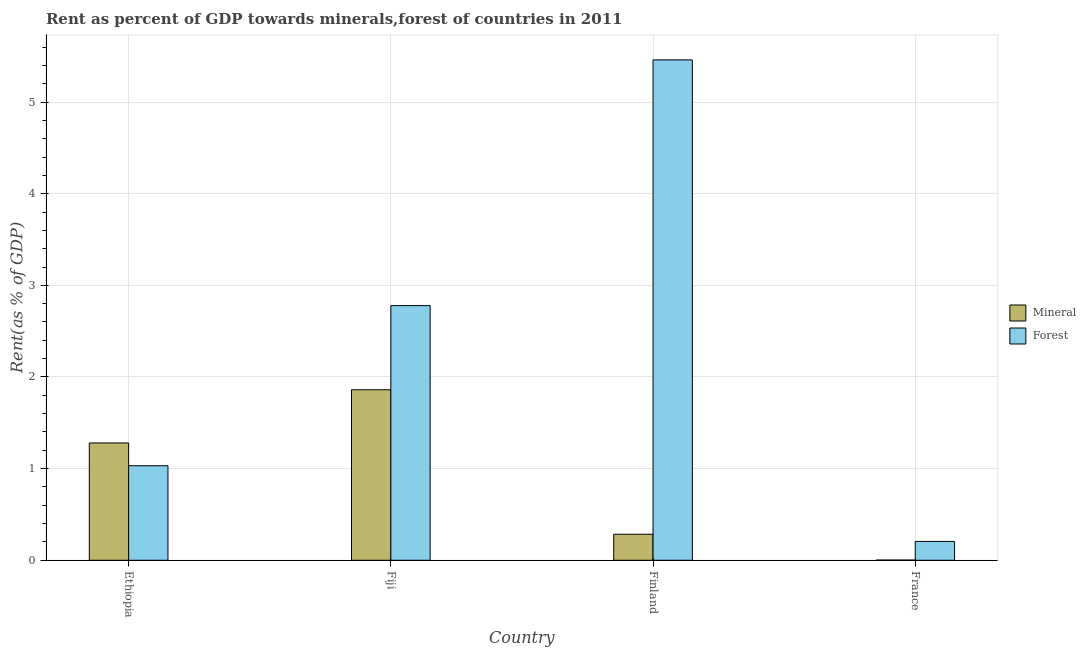How many groups of bars are there?
Offer a terse response. 4. How many bars are there on the 1st tick from the right?
Offer a terse response. 2. What is the label of the 1st group of bars from the left?
Give a very brief answer. Ethiopia. What is the mineral rent in Ethiopia?
Provide a short and direct response. 1.28. Across all countries, what is the maximum mineral rent?
Your answer should be very brief. 1.86. Across all countries, what is the minimum forest rent?
Provide a succinct answer. 0.21. What is the total mineral rent in the graph?
Offer a terse response. 3.43. What is the difference between the mineral rent in Ethiopia and that in Fiji?
Your answer should be compact. -0.58. What is the difference between the mineral rent in Fiji and the forest rent in Ethiopia?
Make the answer very short. 0.83. What is the average forest rent per country?
Offer a terse response. 2.37. What is the difference between the forest rent and mineral rent in Ethiopia?
Provide a succinct answer. -0.25. In how many countries, is the mineral rent greater than 5.2 %?
Offer a terse response. 0. What is the ratio of the mineral rent in Finland to that in France?
Provide a succinct answer. 131.69. What is the difference between the highest and the second highest forest rent?
Your answer should be very brief. 2.68. What is the difference between the highest and the lowest mineral rent?
Your answer should be very brief. 1.86. What does the 2nd bar from the left in Ethiopia represents?
Provide a short and direct response. Forest. What does the 1st bar from the right in France represents?
Ensure brevity in your answer.  Forest. Are all the bars in the graph horizontal?
Give a very brief answer. No. What is the difference between two consecutive major ticks on the Y-axis?
Provide a succinct answer. 1. Where does the legend appear in the graph?
Your answer should be compact. Center right. How many legend labels are there?
Your answer should be very brief. 2. How are the legend labels stacked?
Provide a short and direct response. Vertical. What is the title of the graph?
Give a very brief answer. Rent as percent of GDP towards minerals,forest of countries in 2011. Does "Services" appear as one of the legend labels in the graph?
Your answer should be compact. No. What is the label or title of the Y-axis?
Give a very brief answer. Rent(as % of GDP). What is the Rent(as % of GDP) in Mineral in Ethiopia?
Offer a terse response. 1.28. What is the Rent(as % of GDP) of Forest in Ethiopia?
Your response must be concise. 1.03. What is the Rent(as % of GDP) in Mineral in Fiji?
Offer a very short reply. 1.86. What is the Rent(as % of GDP) of Forest in Fiji?
Offer a very short reply. 2.78. What is the Rent(as % of GDP) of Mineral in Finland?
Provide a succinct answer. 0.28. What is the Rent(as % of GDP) in Forest in Finland?
Your response must be concise. 5.46. What is the Rent(as % of GDP) in Mineral in France?
Offer a very short reply. 0. What is the Rent(as % of GDP) of Forest in France?
Ensure brevity in your answer.  0.21. Across all countries, what is the maximum Rent(as % of GDP) of Mineral?
Give a very brief answer. 1.86. Across all countries, what is the maximum Rent(as % of GDP) of Forest?
Your response must be concise. 5.46. Across all countries, what is the minimum Rent(as % of GDP) of Mineral?
Your answer should be compact. 0. Across all countries, what is the minimum Rent(as % of GDP) in Forest?
Give a very brief answer. 0.21. What is the total Rent(as % of GDP) in Mineral in the graph?
Your answer should be very brief. 3.43. What is the total Rent(as % of GDP) in Forest in the graph?
Ensure brevity in your answer.  9.48. What is the difference between the Rent(as % of GDP) of Mineral in Ethiopia and that in Fiji?
Offer a terse response. -0.58. What is the difference between the Rent(as % of GDP) of Forest in Ethiopia and that in Fiji?
Offer a very short reply. -1.75. What is the difference between the Rent(as % of GDP) of Forest in Ethiopia and that in Finland?
Your answer should be very brief. -4.43. What is the difference between the Rent(as % of GDP) in Mineral in Ethiopia and that in France?
Ensure brevity in your answer.  1.28. What is the difference between the Rent(as % of GDP) in Forest in Ethiopia and that in France?
Offer a terse response. 0.83. What is the difference between the Rent(as % of GDP) of Mineral in Fiji and that in Finland?
Your answer should be compact. 1.58. What is the difference between the Rent(as % of GDP) in Forest in Fiji and that in Finland?
Make the answer very short. -2.68. What is the difference between the Rent(as % of GDP) of Mineral in Fiji and that in France?
Make the answer very short. 1.86. What is the difference between the Rent(as % of GDP) of Forest in Fiji and that in France?
Keep it short and to the point. 2.57. What is the difference between the Rent(as % of GDP) of Mineral in Finland and that in France?
Keep it short and to the point. 0.28. What is the difference between the Rent(as % of GDP) of Forest in Finland and that in France?
Your response must be concise. 5.25. What is the difference between the Rent(as % of GDP) of Mineral in Ethiopia and the Rent(as % of GDP) of Forest in Fiji?
Make the answer very short. -1.5. What is the difference between the Rent(as % of GDP) of Mineral in Ethiopia and the Rent(as % of GDP) of Forest in Finland?
Give a very brief answer. -4.18. What is the difference between the Rent(as % of GDP) of Mineral in Ethiopia and the Rent(as % of GDP) of Forest in France?
Your answer should be very brief. 1.07. What is the difference between the Rent(as % of GDP) in Mineral in Fiji and the Rent(as % of GDP) in Forest in Finland?
Your answer should be very brief. -3.6. What is the difference between the Rent(as % of GDP) in Mineral in Fiji and the Rent(as % of GDP) in Forest in France?
Offer a very short reply. 1.66. What is the difference between the Rent(as % of GDP) in Mineral in Finland and the Rent(as % of GDP) in Forest in France?
Make the answer very short. 0.08. What is the average Rent(as % of GDP) in Mineral per country?
Offer a very short reply. 0.86. What is the average Rent(as % of GDP) in Forest per country?
Your answer should be compact. 2.37. What is the difference between the Rent(as % of GDP) of Mineral and Rent(as % of GDP) of Forest in Ethiopia?
Your answer should be very brief. 0.25. What is the difference between the Rent(as % of GDP) in Mineral and Rent(as % of GDP) in Forest in Fiji?
Your answer should be compact. -0.92. What is the difference between the Rent(as % of GDP) of Mineral and Rent(as % of GDP) of Forest in Finland?
Offer a very short reply. -5.18. What is the difference between the Rent(as % of GDP) in Mineral and Rent(as % of GDP) in Forest in France?
Your answer should be compact. -0.2. What is the ratio of the Rent(as % of GDP) of Mineral in Ethiopia to that in Fiji?
Give a very brief answer. 0.69. What is the ratio of the Rent(as % of GDP) of Forest in Ethiopia to that in Fiji?
Your answer should be very brief. 0.37. What is the ratio of the Rent(as % of GDP) of Mineral in Ethiopia to that in Finland?
Your response must be concise. 4.51. What is the ratio of the Rent(as % of GDP) of Forest in Ethiopia to that in Finland?
Offer a very short reply. 0.19. What is the ratio of the Rent(as % of GDP) in Mineral in Ethiopia to that in France?
Provide a succinct answer. 593.69. What is the ratio of the Rent(as % of GDP) in Forest in Ethiopia to that in France?
Your answer should be very brief. 5.02. What is the ratio of the Rent(as % of GDP) in Mineral in Fiji to that in Finland?
Provide a short and direct response. 6.55. What is the ratio of the Rent(as % of GDP) in Forest in Fiji to that in Finland?
Give a very brief answer. 0.51. What is the ratio of the Rent(as % of GDP) of Mineral in Fiji to that in France?
Make the answer very short. 862.97. What is the ratio of the Rent(as % of GDP) in Forest in Fiji to that in France?
Provide a short and direct response. 13.52. What is the ratio of the Rent(as % of GDP) of Mineral in Finland to that in France?
Keep it short and to the point. 131.69. What is the ratio of the Rent(as % of GDP) in Forest in Finland to that in France?
Ensure brevity in your answer.  26.57. What is the difference between the highest and the second highest Rent(as % of GDP) in Mineral?
Keep it short and to the point. 0.58. What is the difference between the highest and the second highest Rent(as % of GDP) of Forest?
Offer a very short reply. 2.68. What is the difference between the highest and the lowest Rent(as % of GDP) in Mineral?
Your answer should be compact. 1.86. What is the difference between the highest and the lowest Rent(as % of GDP) in Forest?
Make the answer very short. 5.25. 